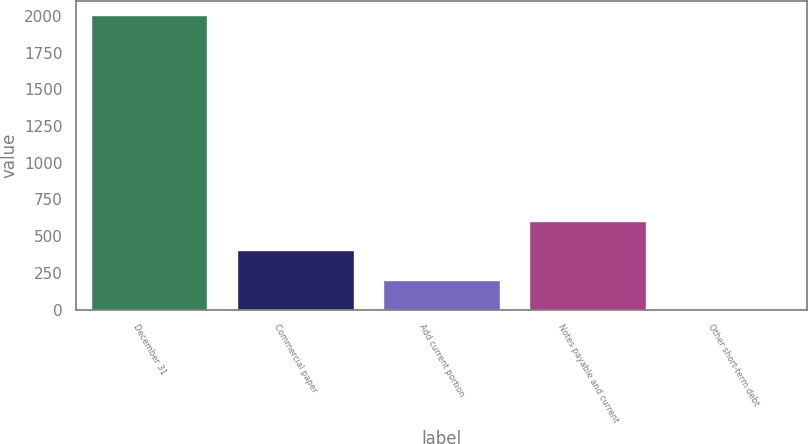<chart> <loc_0><loc_0><loc_500><loc_500><bar_chart><fcel>December 31<fcel>Commercial paper<fcel>Add current portion<fcel>Notes payable and current<fcel>Other short-term debt<nl><fcel>2005<fcel>403.72<fcel>203.56<fcel>603.88<fcel>3.4<nl></chart> 